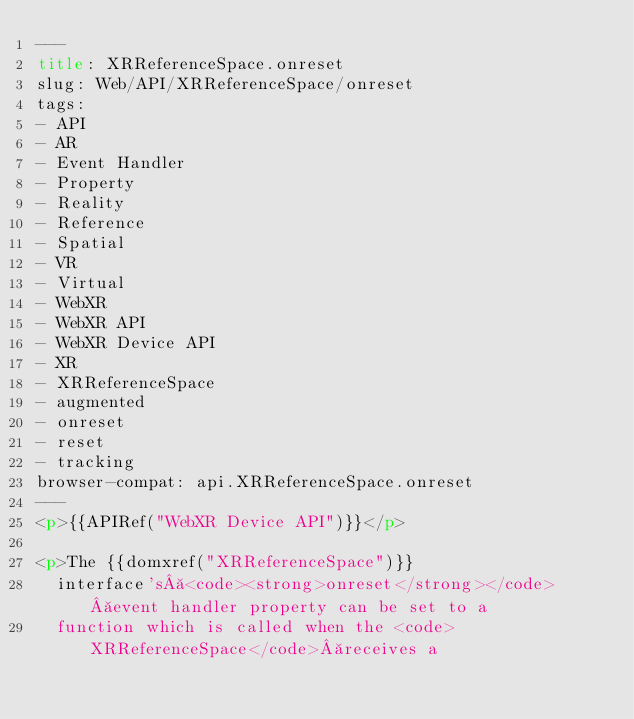Convert code to text. <code><loc_0><loc_0><loc_500><loc_500><_HTML_>---
title: XRReferenceSpace.onreset
slug: Web/API/XRReferenceSpace/onreset
tags:
- API
- AR
- Event Handler
- Property
- Reality
- Reference
- Spatial
- VR
- Virtual
- WebXR
- WebXR API
- WebXR Device API
- XR
- XRReferenceSpace
- augmented
- onreset
- reset
- tracking
browser-compat: api.XRReferenceSpace.onreset
---
<p>{{APIRef("WebXR Device API")}}</p>

<p>The {{domxref("XRReferenceSpace")}}
  interface's <code><strong>onreset</strong></code> event handler property can be set to a
  function which is called when the <code>XRReferenceSpace</code> receives a</code> 